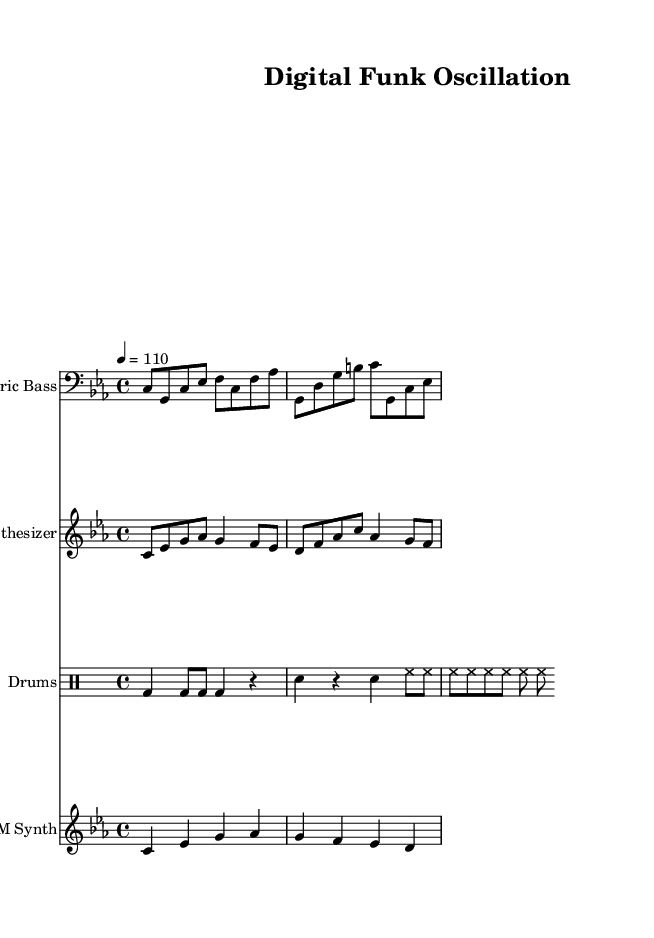What is the key signature of this music? The key signature is C minor, which has three flats (B flat, E flat, A flat). You can identify the key signature in the beginning of the score indicated by the B flat, E flat, and A flat symbols.
Answer: C minor What is the time signature of this music? The time signature is found at the beginning of the score, represented as 4/4. This indicates that there are four beats in every measure and that a quarter note gets one beat.
Answer: 4/4 What is the tempo marking? The tempo marking is indicated in the score as "4 = 110", meaning that there are 110 beats per minute with the quarter note counted as one beat. This information is usually found near the top of the score.
Answer: 110 How many instruments are featured in the piece? By analyzing the score, we can see there are four staves, each labeled with a different instrument name: Electric Bass, Synthesizer, Drums, and FM Synth. This gives a total of four instruments throughout the piece.
Answer: Four What rhythmic pattern do the drums follow? The drum pattern can be identified in the drum staff, which displays different note rows for bass drum (bd), snare (sn), and hi-hat (hh). The pattern includes a mix of quarter notes and eighth notes.
Answer: Mixed What type of synthesis is primarily used in this score? The score lists "FM Synth," which stands for Frequency Modulation Synthesis. This type of synthesis is commonly used in funk music for creating rich, complex sounds, indicated by the specific staff labeled for this instrument.
Answer: Frequency Modulation What is the overall music style represented here? Given the title "Digital Funk Oscillation," as well as the rhythmic and harmonic elements present in the score, this piece falls within the genre of experimental funk that incorporates contemporary techniques. The style combines traditional funk elements with new sound wave manipulation.
Answer: Experimental funk 